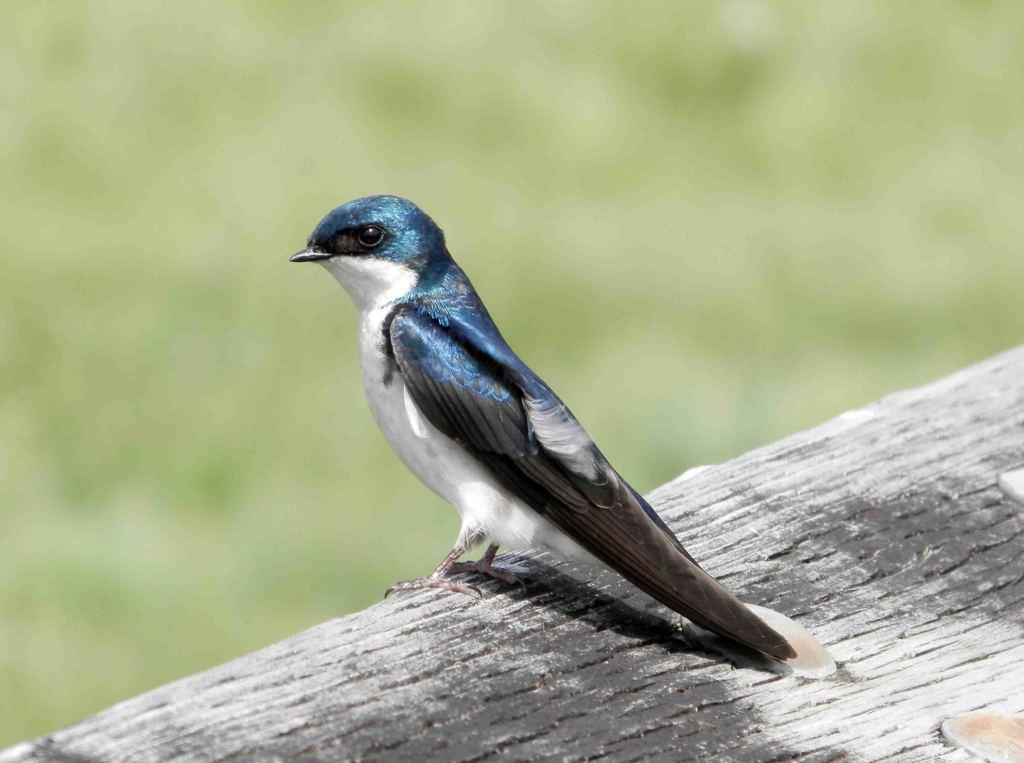Describe this image in one or two sentences. In this image I can see the bird on the wooden surface. I can see the bird is in blue, black and white color. And there is a blurred background. 